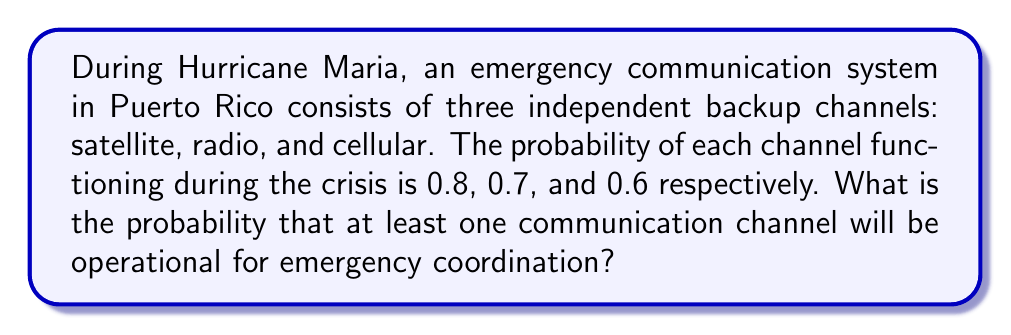Teach me how to tackle this problem. Let's approach this step-by-step:

1) First, we need to understand that we're looking for the probability of at least one channel working. It's often easier to calculate the complement of this: the probability that none of the channels are working.

2) Let's define our events:
   S: Satellite channel works
   R: Radio channel works
   C: Cellular channel works

3) We're given:
   P(S) = 0.8
   P(R) = 0.7
   P(C) = 0.6

4) The probability that a channel doesn't work is 1 minus the probability that it does work:
   P(not S) = 1 - 0.8 = 0.2
   P(not R) = 1 - 0.7 = 0.3
   P(not C) = 1 - 0.6 = 0.4

5) For no channels to work, all three must fail. Since the channels are independent, we multiply these probabilities:

   P(no channels work) = P(not S) × P(not R) × P(not C)
                       = 0.2 × 0.3 × 0.4
                       = 0.024

6) Therefore, the probability that at least one channel works is:

   P(at least one works) = 1 - P(no channels work)
                         = 1 - 0.024
                         = 0.976

Thus, there is a 0.976 or 97.6% chance that at least one communication channel will be operational.
Answer: 0.976 